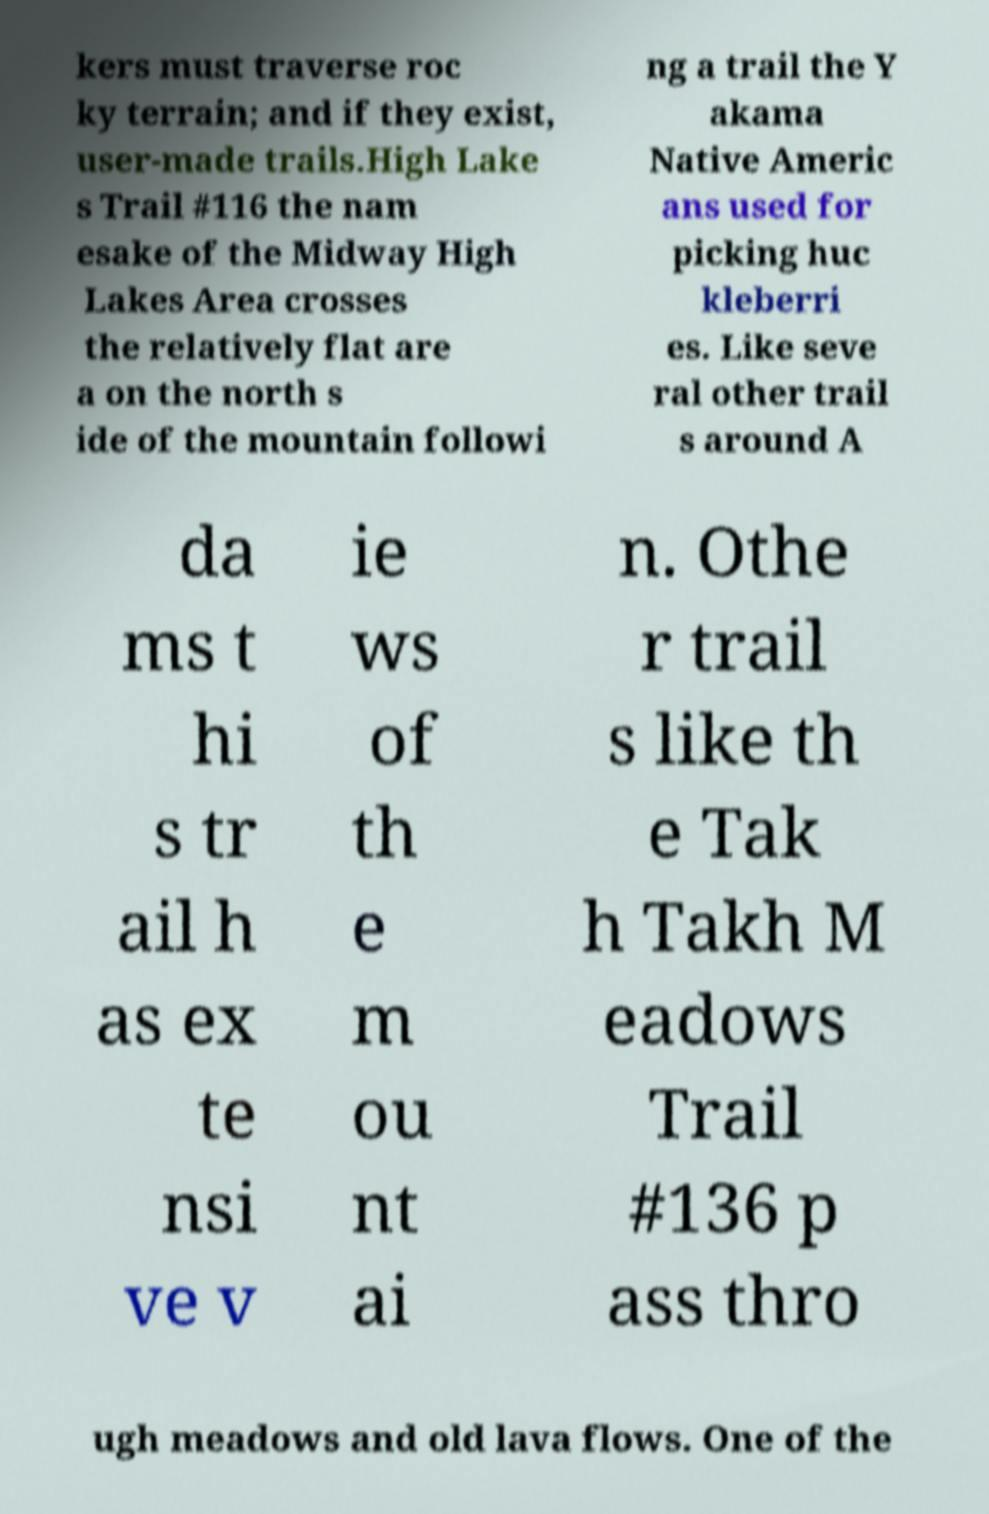Please identify and transcribe the text found in this image. kers must traverse roc ky terrain; and if they exist, user-made trails.High Lake s Trail #116 the nam esake of the Midway High Lakes Area crosses the relatively flat are a on the north s ide of the mountain followi ng a trail the Y akama Native Americ ans used for picking huc kleberri es. Like seve ral other trail s around A da ms t hi s tr ail h as ex te nsi ve v ie ws of th e m ou nt ai n. Othe r trail s like th e Tak h Takh M eadows Trail #136 p ass thro ugh meadows and old lava flows. One of the 